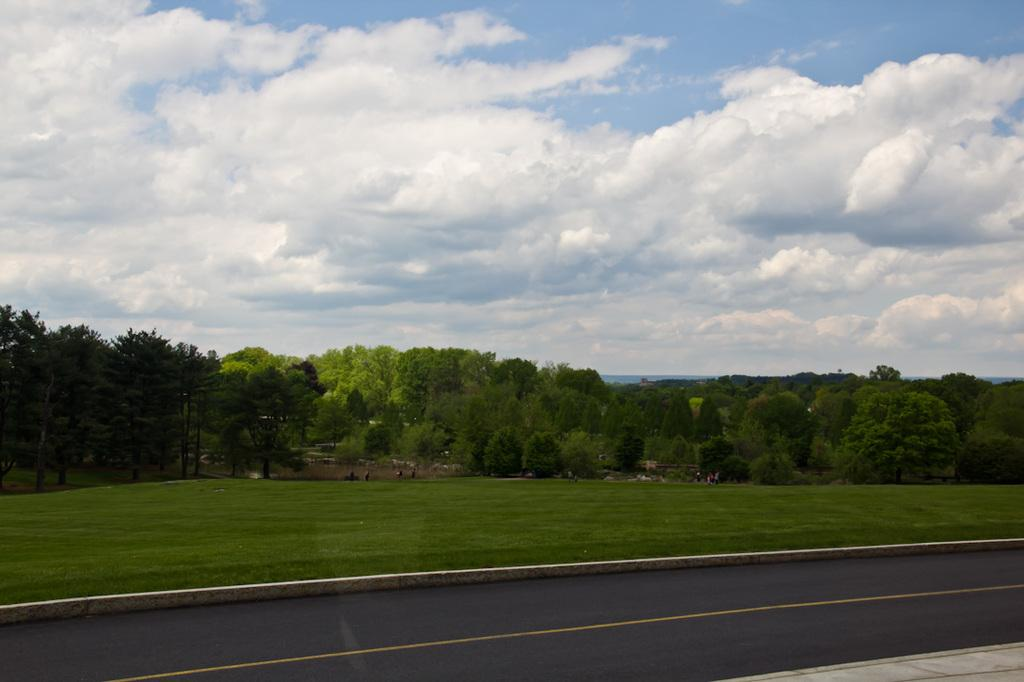What is located at the bottom of the image? There is a road at the bottom of the image. What can be seen in the middle of the image? There are trees in the middle of the image. What is visible at the top of the image? The sky is visible at the top of the image. How many women are celebrating a birthday in the image? There are no women or birthday celebrations present in the image. What type of addition is being performed by the trees in the image? There is no addition being performed by the trees in the image; they are simply standing in the middle of the image. 